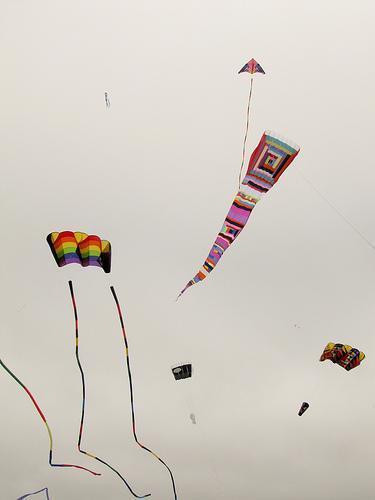How many kites are in this picture?
Give a very brief answer. 5. 